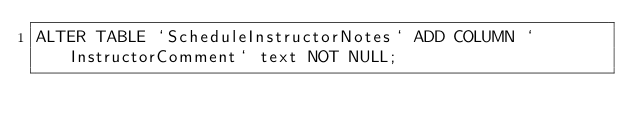Convert code to text. <code><loc_0><loc_0><loc_500><loc_500><_SQL_>ALTER TABLE `ScheduleInstructorNotes` ADD COLUMN `InstructorComment` text NOT NULL;</code> 